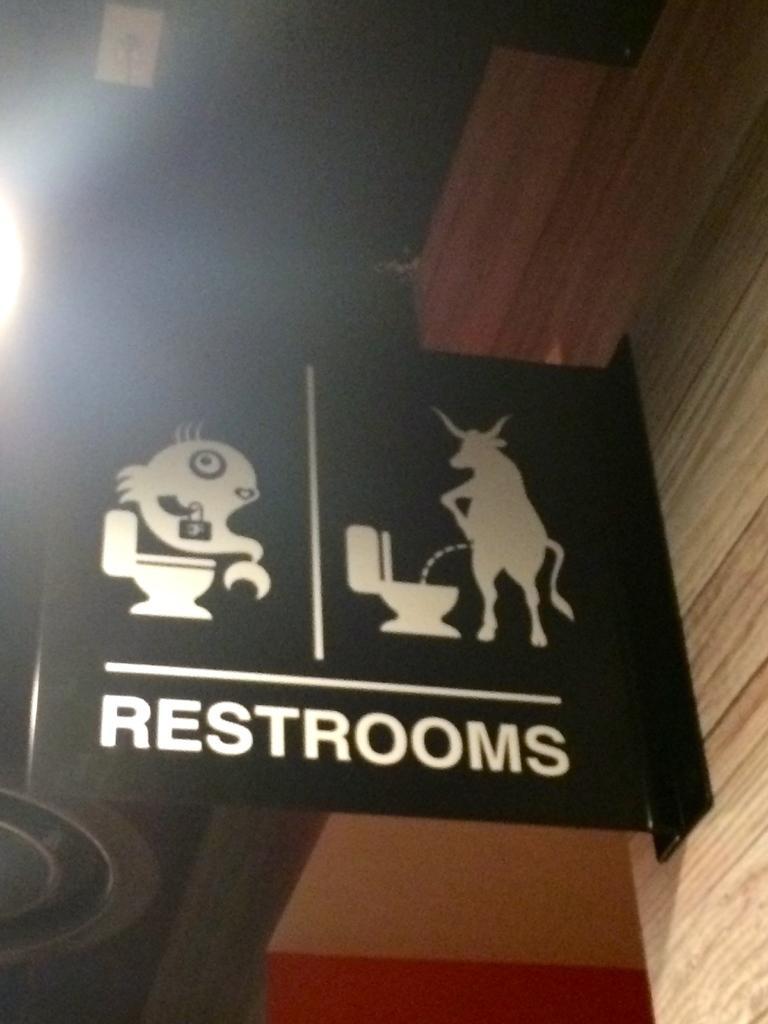Can you describe this image briefly? In this image I can see the black color board to the wall. And I can see the name restrooms is written on it. To the left I can see the light. 